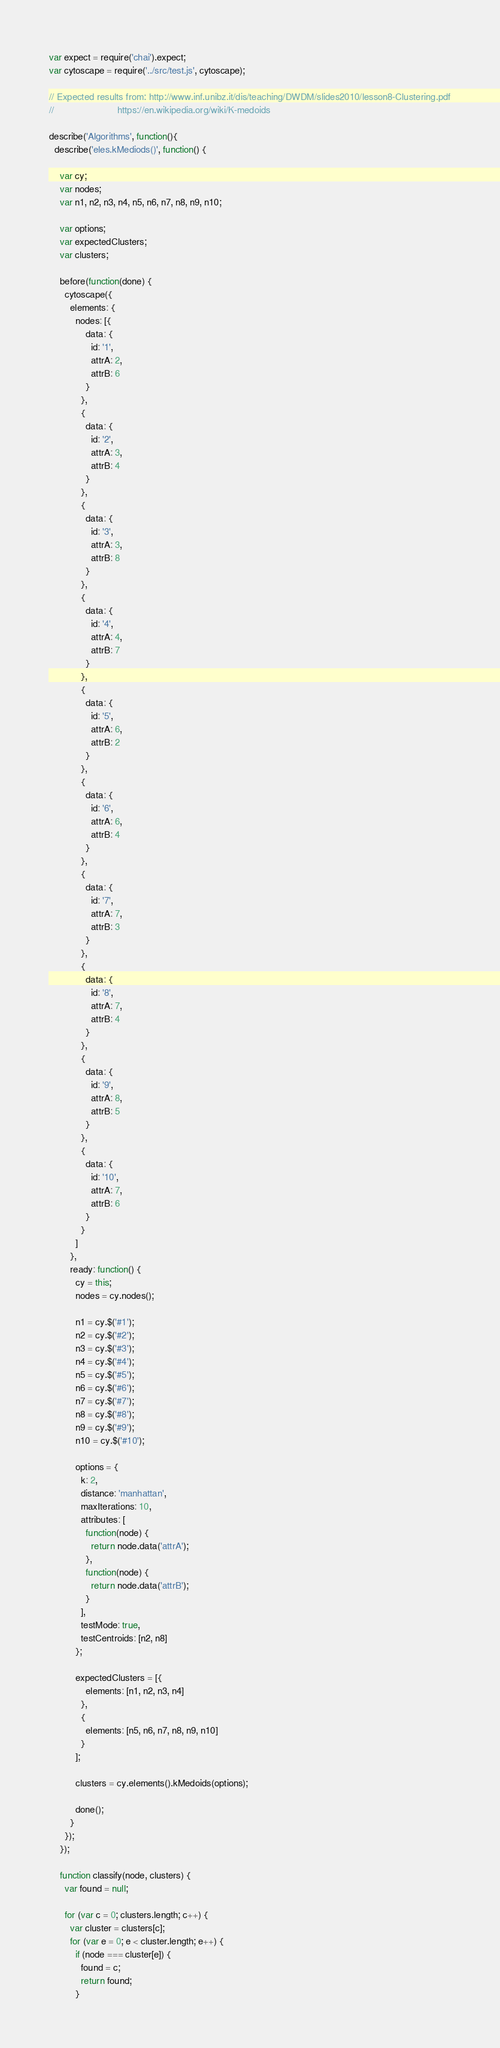<code> <loc_0><loc_0><loc_500><loc_500><_JavaScript_>var expect = require('chai').expect;
var cytoscape = require('../src/test.js', cytoscape);

// Expected results from: http://www.inf.unibz.it/dis/teaching/DWDM/slides2010/lesson8-Clustering.pdf
//                        https://en.wikipedia.org/wiki/K-medoids

describe('Algorithms', function(){
  describe('eles.kMediods()', function() {

    var cy;
    var nodes;
    var n1, n2, n3, n4, n5, n6, n7, n8, n9, n10;

    var options;
    var expectedClusters;
    var clusters;

    before(function(done) {
      cytoscape({
        elements: {
          nodes: [{
              data: {
                id: '1',
                attrA: 2,
                attrB: 6
              }
            },
            {
              data: {
                id: '2',
                attrA: 3,
                attrB: 4
              }
            },
            {
              data: {
                id: '3',
                attrA: 3,
                attrB: 8
              }
            },
            {
              data: {
                id: '4',
                attrA: 4,
                attrB: 7
              }
            },
            {
              data: {
                id: '5',
                attrA: 6,
                attrB: 2
              }
            },
            {
              data: {
                id: '6',
                attrA: 6,
                attrB: 4
              }
            },
            {
              data: {
                id: '7',
                attrA: 7,
                attrB: 3
              }
            },
            {
              data: {
                id: '8',
                attrA: 7,
                attrB: 4
              }
            },
            {
              data: {
                id: '9',
                attrA: 8,
                attrB: 5
              }
            },
            {
              data: {
                id: '10',
                attrA: 7,
                attrB: 6
              }
            }
          ]
        },
        ready: function() {
          cy = this;
          nodes = cy.nodes();

          n1 = cy.$('#1');
          n2 = cy.$('#2');
          n3 = cy.$('#3');
          n4 = cy.$('#4');
          n5 = cy.$('#5');
          n6 = cy.$('#6');
          n7 = cy.$('#7');
          n8 = cy.$('#8');
          n9 = cy.$('#9');
          n10 = cy.$('#10');

          options = {
            k: 2,
            distance: 'manhattan',
            maxIterations: 10,
            attributes: [
              function(node) {
                return node.data('attrA');
              },
              function(node) {
                return node.data('attrB');
              }
            ],
            testMode: true,
            testCentroids: [n2, n8]
          };

          expectedClusters = [{
              elements: [n1, n2, n3, n4]
            },
            {
              elements: [n5, n6, n7, n8, n9, n10]
            }
          ];

          clusters = cy.elements().kMedoids(options);

          done();
        }
      });
    });

    function classify(node, clusters) {
      var found = null;

      for (var c = 0; clusters.length; c++) {
        var cluster = clusters[c];
        for (var e = 0; e < cluster.length; e++) {
          if (node === cluster[e]) {
            found = c;
            return found;
          }</code> 